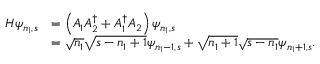Convert formula to latex. <formula><loc_0><loc_0><loc_500><loc_500>\begin{array} { r l } { H \psi _ { n _ { 1 } , s } } & { = \left ( A _ { 1 } A _ { 2 } ^ { \dagger } + A _ { 1 } ^ { \dagger } A _ { 2 } \right ) \psi _ { n _ { 1 } , s } } \\ & { = \sqrt { n _ { 1 } } \sqrt { s - n _ { 1 } + 1 } \psi _ { n _ { 1 } - 1 , s } + \sqrt { n _ { 1 } + 1 } \sqrt { s - n _ { 1 } } \psi _ { n _ { 1 } + 1 , s } . } \end{array}</formula> 